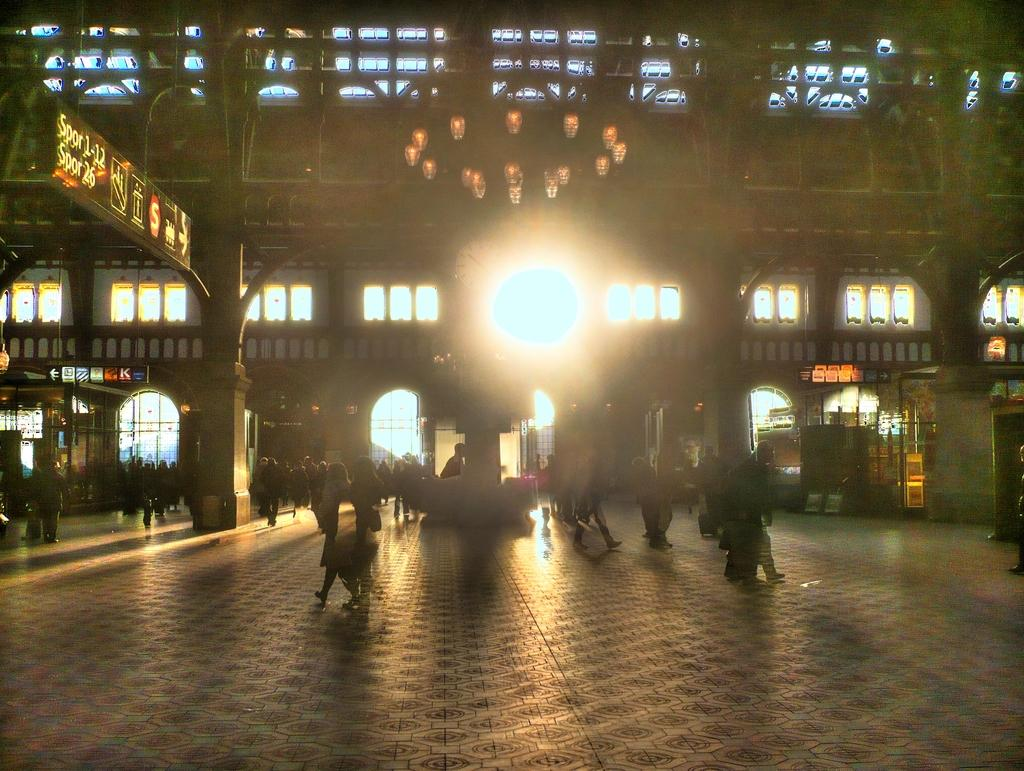What are the people in the image doing? The people in the image are walking. What structure can be seen in the image? There is a building in the image. What is located in the middle of the image? There is a light in the middle of the image. What type of fuel can be seen being used by the people walking in the image? There is no fuel visible in the image, as people typically do not use fuel to walk. 